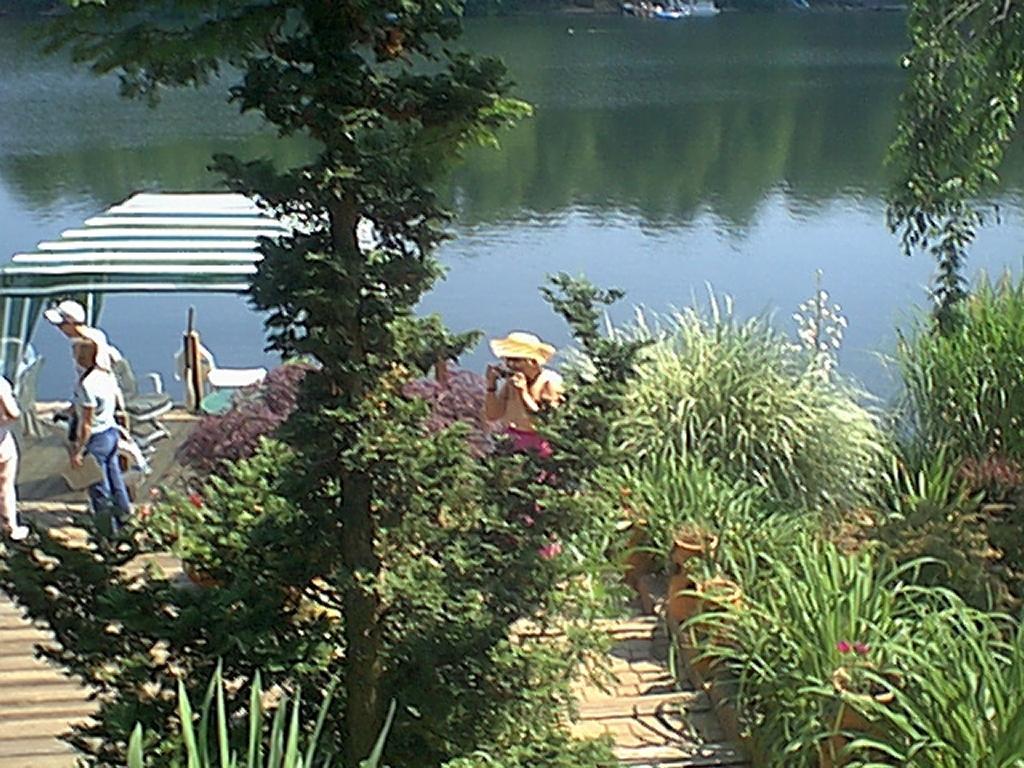Could you give a brief overview of what you see in this image? On the left side, we see three people are standing. Beside them, we see the wall. We see the chairs and table under the white tent like. The woman in the middle of the picture is standing and I think she is clicking photos on the mobile phone. At the bottom of the picture, we see plants and trees. In the background, we see water and this water might be in the canal. 